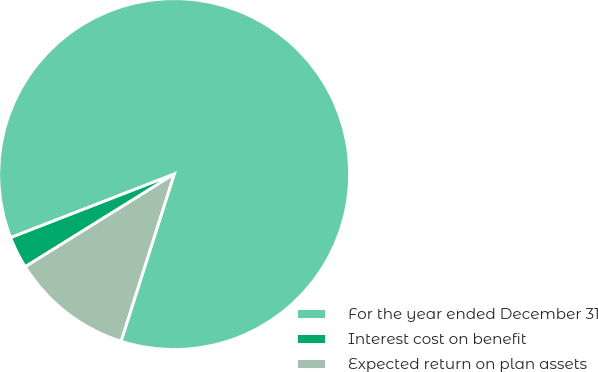Convert chart to OTSL. <chart><loc_0><loc_0><loc_500><loc_500><pie_chart><fcel>For the year ended December 31<fcel>Interest cost on benefit<fcel>Expected return on plan assets<nl><fcel>85.8%<fcel>2.96%<fcel>11.24%<nl></chart> 